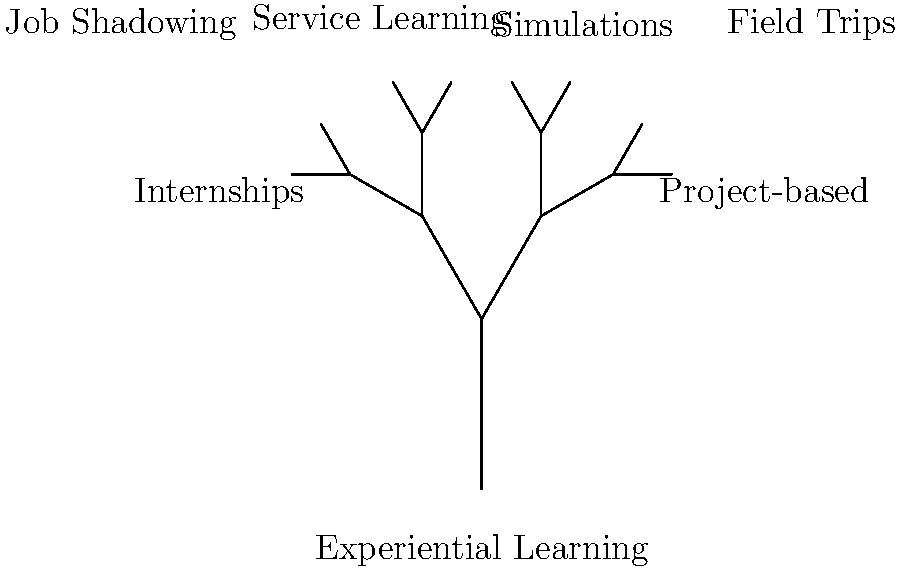Based on the decision tree visualization of experiential learning methods, which approach is most likely to provide students with the most comprehensive real-world experience while aligning with your advocacy for policies promoting experiential learning and internships? To answer this question, let's analyze the decision tree visualization step-by-step:

1. The tree starts with "Experiential Learning" as the root.

2. It then branches into two main categories:
   a) Internships
   b) Project-based learning

3. The internships branch doesn't have further subdivisions, indicating it's a standalone method.

4. The project-based learning branch subdivides into four methods:
   a) Job Shadowing
   b) Service Learning
   c) Simulations
   d) Field Trips

5. Considering the persona of a local representative advocating for policies promoting experiential learning and internships, we need to identify the method that provides the most comprehensive real-world experience.

6. Internships typically offer:
   - Direct workplace experience
   - Extended periods of engagement
   - Opportunities to apply classroom knowledge
   - Professional networking
   - Potential for employment

7. While other methods like job shadowing, service learning, simulations, and field trips all have merits, they generally offer shorter or less immersive experiences compared to internships.

8. Internships align most closely with the representative's advocacy for policies promoting both experiential learning and internships specifically.

Therefore, based on the decision tree and the given persona, internships are most likely to provide students with the most comprehensive real-world experience while aligning with the advocacy goals.
Answer: Internships 